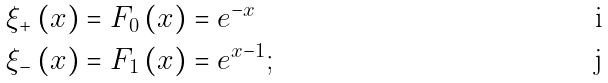Convert formula to latex. <formula><loc_0><loc_0><loc_500><loc_500>\xi _ { + } \left ( x \right ) & = F _ { 0 } \left ( x \right ) = e ^ { - x } \\ \xi _ { - } \left ( x \right ) & = F _ { 1 } \left ( x \right ) = e ^ { x - 1 } ;</formula> 